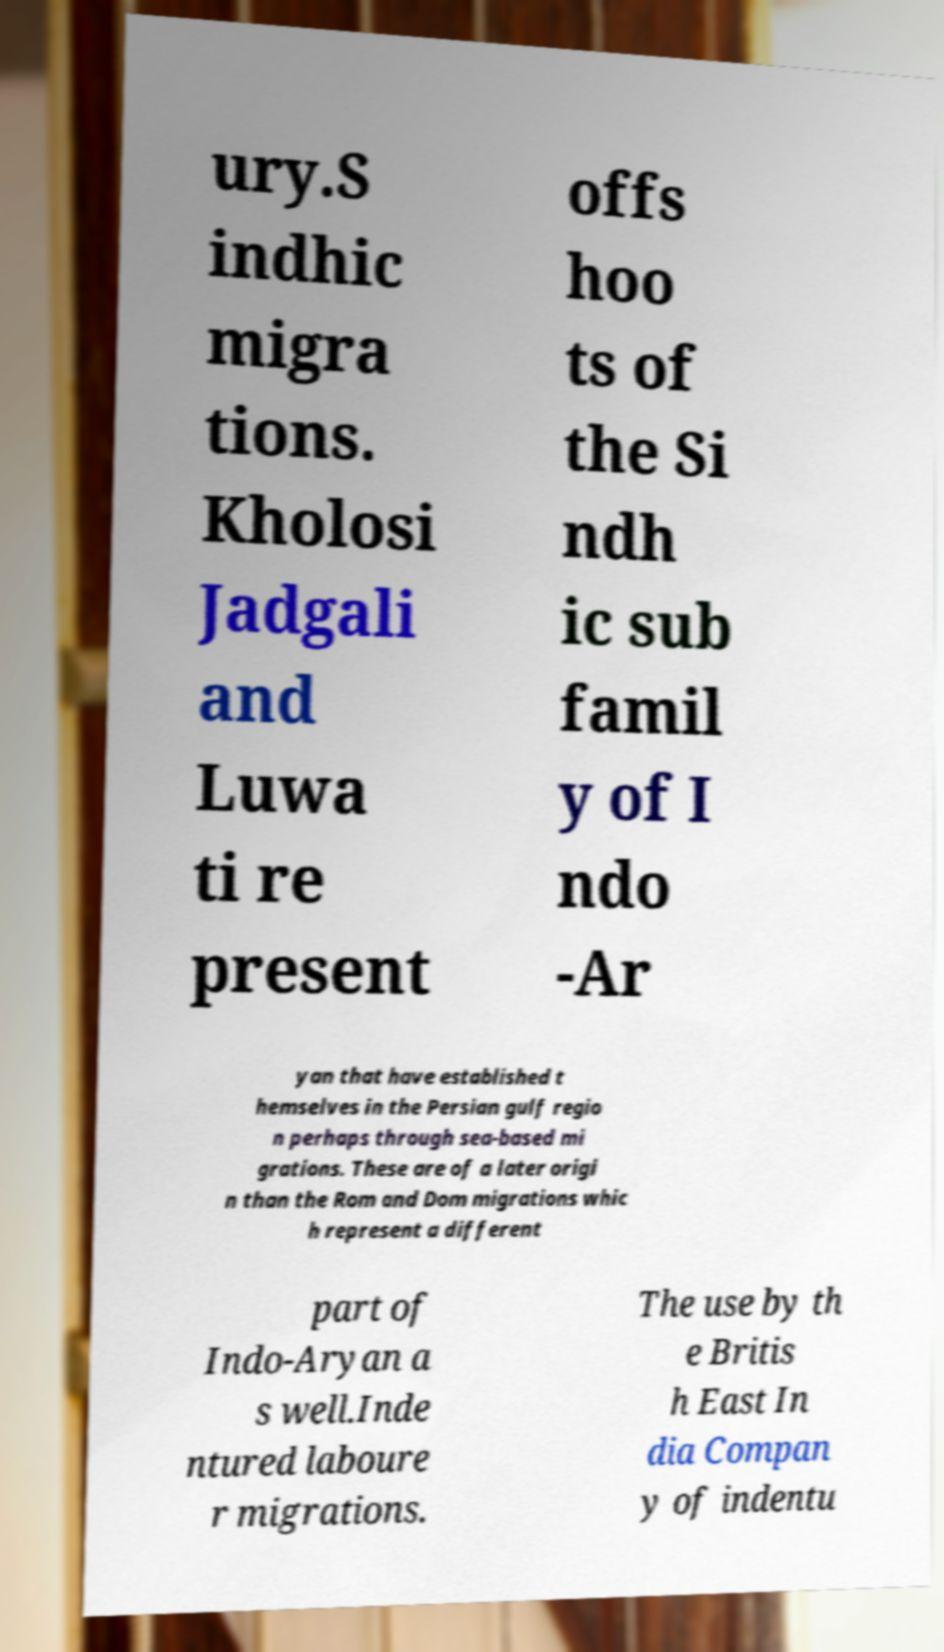Can you read and provide the text displayed in the image?This photo seems to have some interesting text. Can you extract and type it out for me? ury.S indhic migra tions. Kholosi Jadgali and Luwa ti re present offs hoo ts of the Si ndh ic sub famil y of I ndo -Ar yan that have established t hemselves in the Persian gulf regio n perhaps through sea-based mi grations. These are of a later origi n than the Rom and Dom migrations whic h represent a different part of Indo-Aryan a s well.Inde ntured laboure r migrations. The use by th e Britis h East In dia Compan y of indentu 